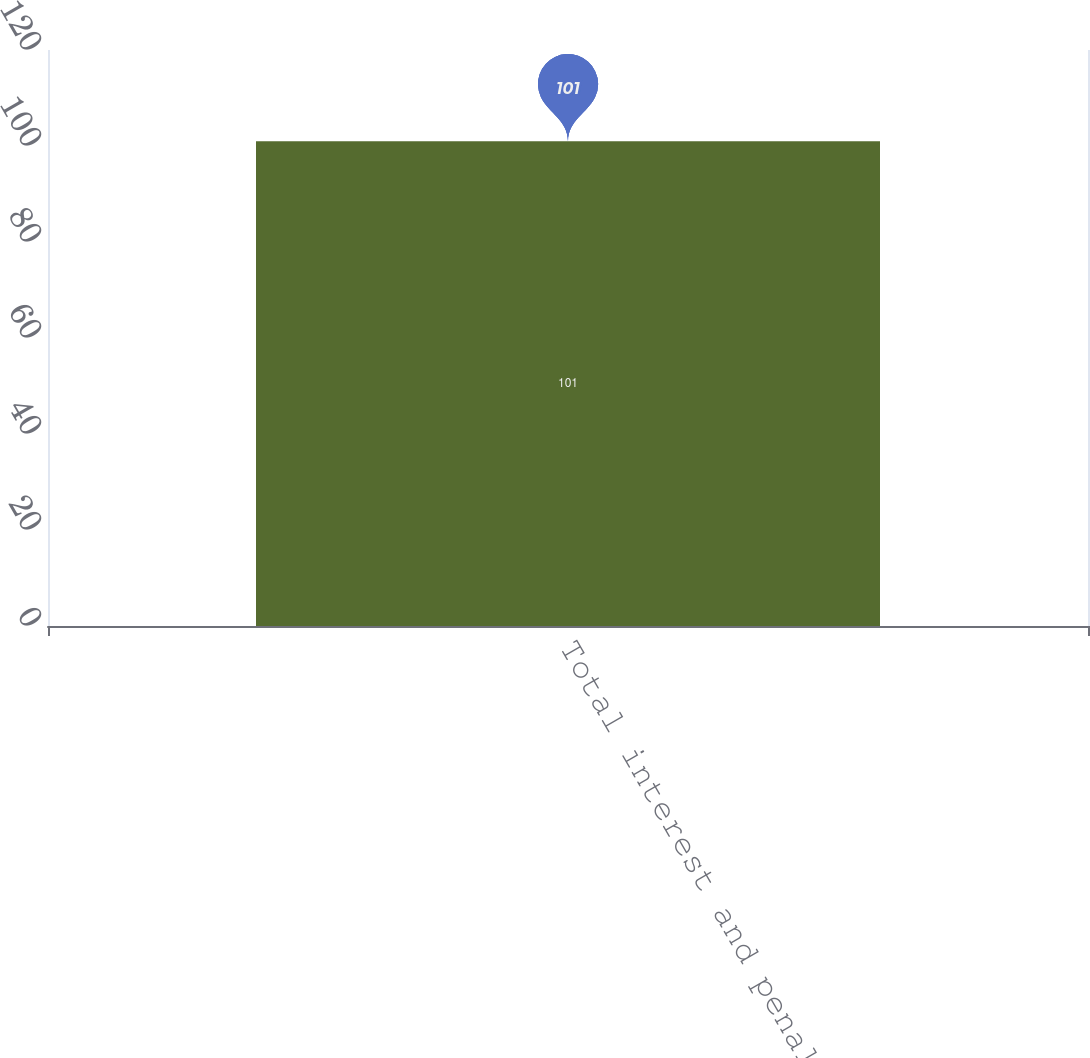Convert chart. <chart><loc_0><loc_0><loc_500><loc_500><bar_chart><fcel>Total interest and penalties<nl><fcel>101<nl></chart> 